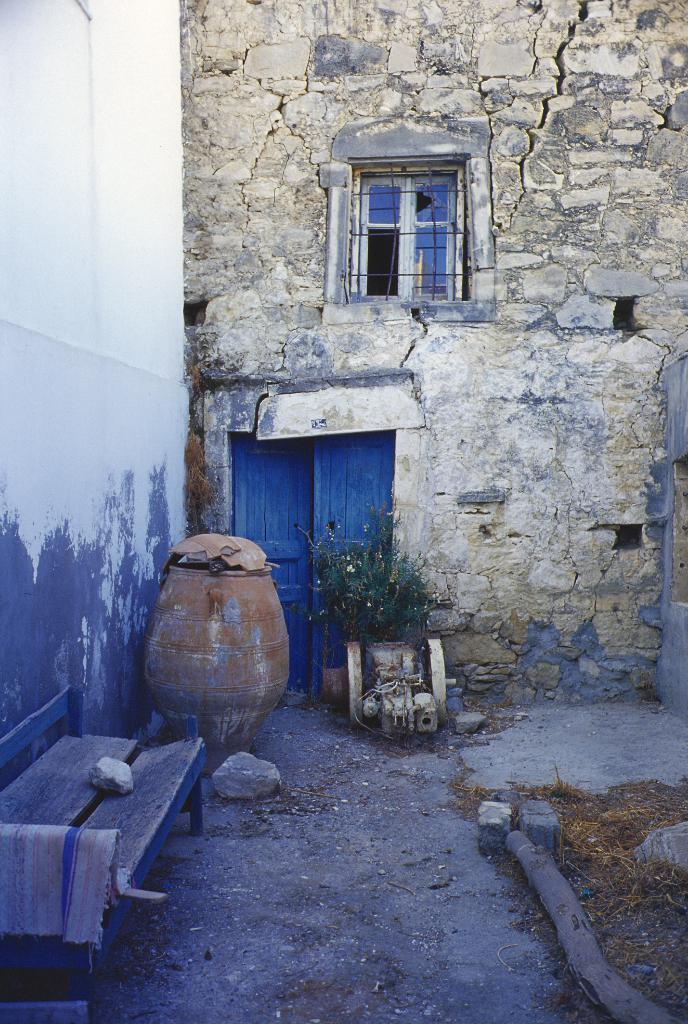What type of structures can be seen in the image? There are walls, a door, and a window visible in the image. What is the ground like in the image? The ground is visible in the image, and there are stones on it. What objects can be found on the ground? There is a container and an object with cloth on it on the ground. What is the brother's desire in the image? There is no brother or desire mentioned in the image; it only shows structures, the ground, and objects. 